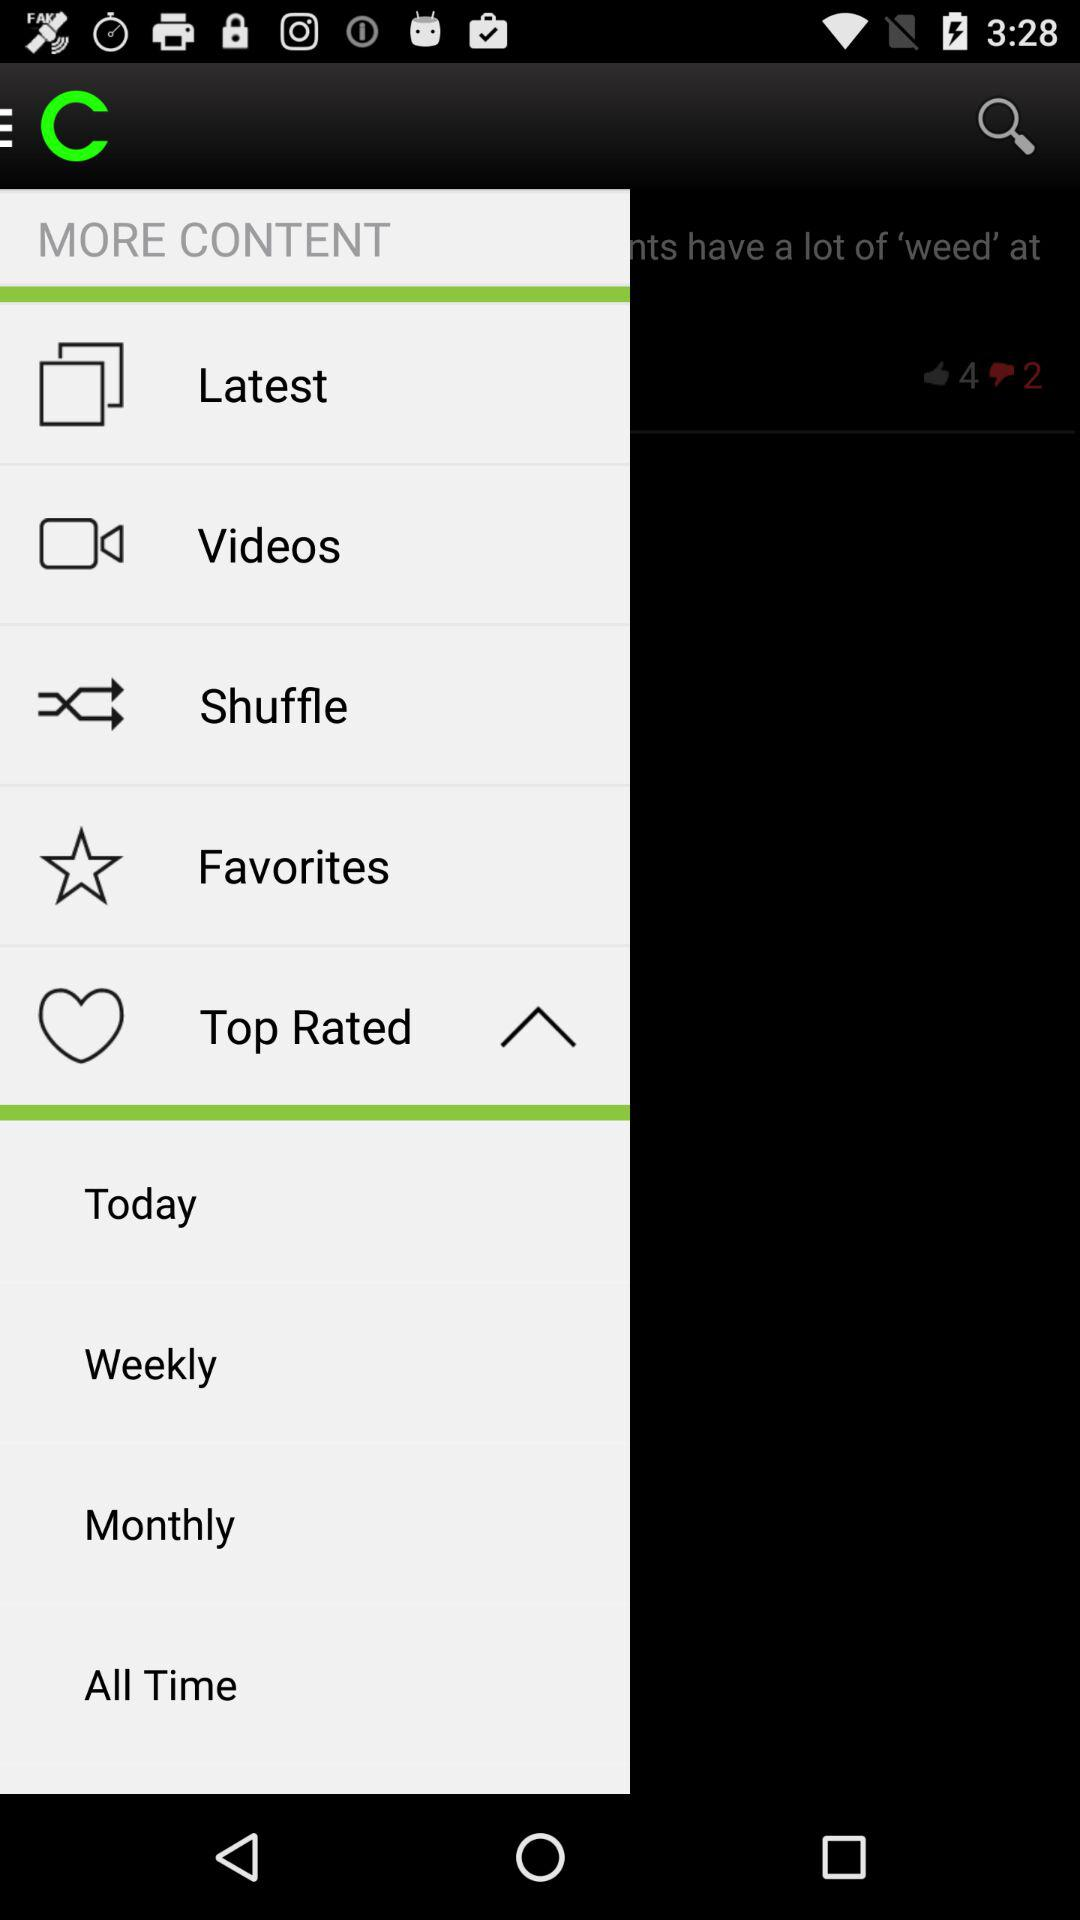How many more thumbs up than thumbs down are there?
Answer the question using a single word or phrase. 2 